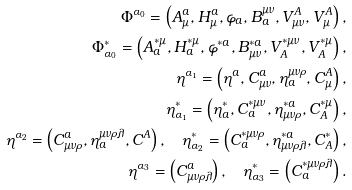Convert formula to latex. <formula><loc_0><loc_0><loc_500><loc_500>\Phi ^ { \alpha _ { 0 } } = \left ( A _ { \mu } ^ { a } , H _ { \mu } ^ { a } , \varphi _ { a } , B _ { a } ^ { \mu \nu } , V _ { \mu \nu } ^ { A } , V _ { \mu } ^ { A } \right ) , \\ \Phi _ { \alpha _ { 0 } } ^ { \ast } = \left ( A _ { a } ^ { \ast \mu } , H _ { a } ^ { \ast \mu } , \varphi ^ { \ast a } , B _ { \mu \nu } ^ { \ast a } , V _ { A } ^ { \ast \mu \nu } , V _ { A } ^ { \ast \mu } \right ) , \\ \eta ^ { \alpha _ { 1 } } = \left ( \eta ^ { a } , C _ { \mu \nu } ^ { a } , \eta _ { a } ^ { \mu \nu \rho } , C _ { \mu } ^ { A } \right ) , \\ \eta _ { \alpha _ { 1 } } ^ { \ast } = \left ( \eta _ { a } ^ { \ast } , C _ { a } ^ { \ast \mu \nu } , \eta _ { \mu \nu \rho } ^ { \ast a } , C _ { A } ^ { \ast \mu } \right ) , \\ \eta ^ { \alpha _ { 2 } } = \left ( C _ { \mu \nu \rho } ^ { a } , \eta _ { a } ^ { \mu \nu \rho \lambda } , C ^ { A } \right ) , \quad \eta _ { \alpha _ { 2 } } ^ { \ast } = \left ( C _ { a } ^ { \ast \mu \nu \rho } , \eta _ { \mu \nu \rho \lambda } ^ { \ast a } , C _ { A } ^ { \ast } \right ) , \\ \eta ^ { \alpha _ { 3 } } = \left ( C _ { \mu \nu \rho \lambda } ^ { a } \right ) , \quad \eta _ { \alpha _ { 3 } } ^ { \ast } = \left ( C _ { a } ^ { \ast \mu \nu \rho \lambda } \right ) .</formula> 